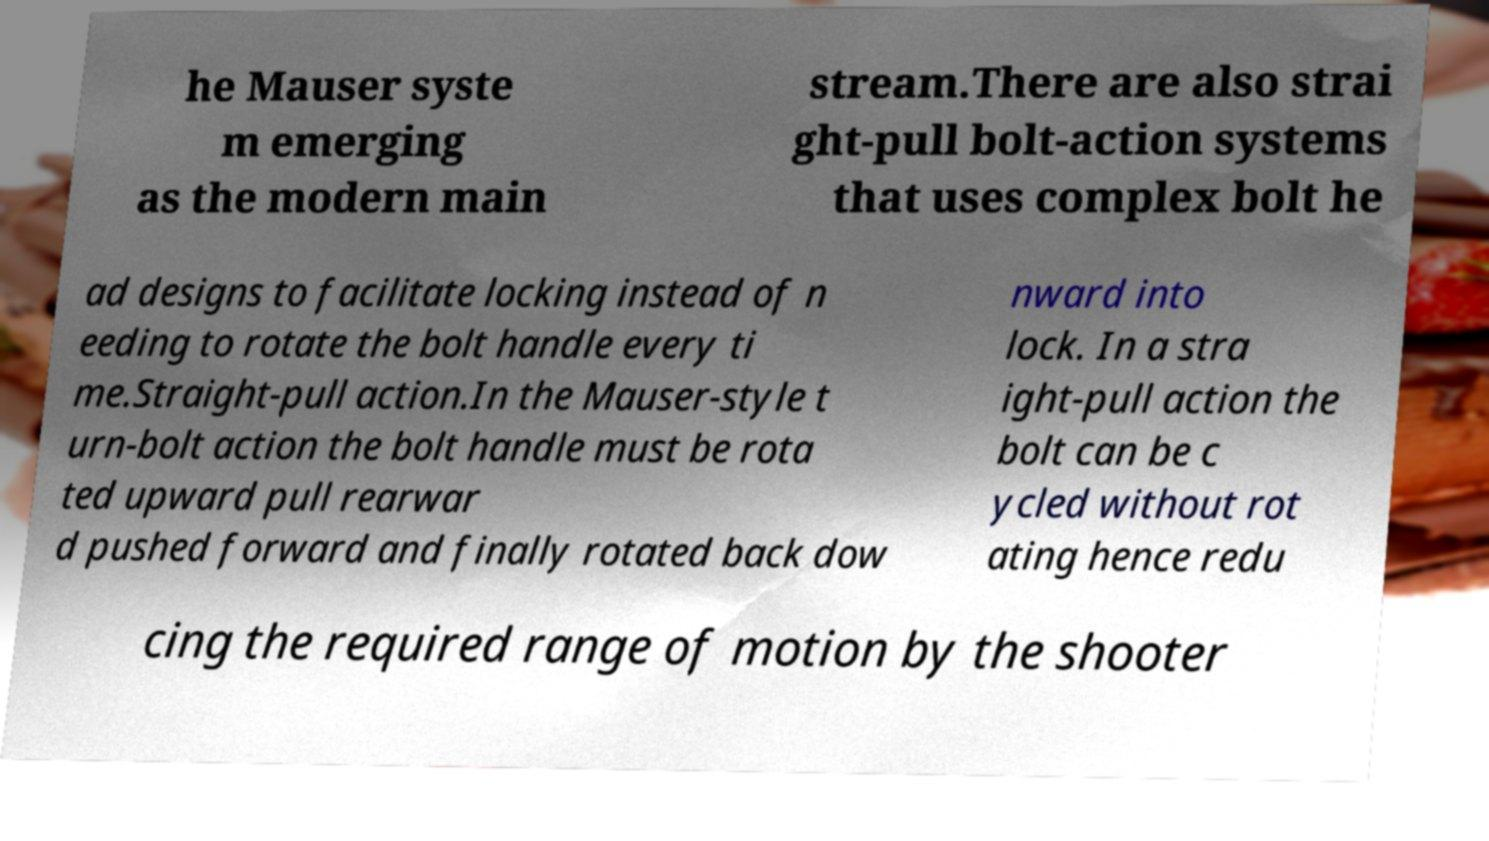Please read and relay the text visible in this image. What does it say? he Mauser syste m emerging as the modern main stream.There are also strai ght-pull bolt-action systems that uses complex bolt he ad designs to facilitate locking instead of n eeding to rotate the bolt handle every ti me.Straight-pull action.In the Mauser-style t urn-bolt action the bolt handle must be rota ted upward pull rearwar d pushed forward and finally rotated back dow nward into lock. In a stra ight-pull action the bolt can be c ycled without rot ating hence redu cing the required range of motion by the shooter 